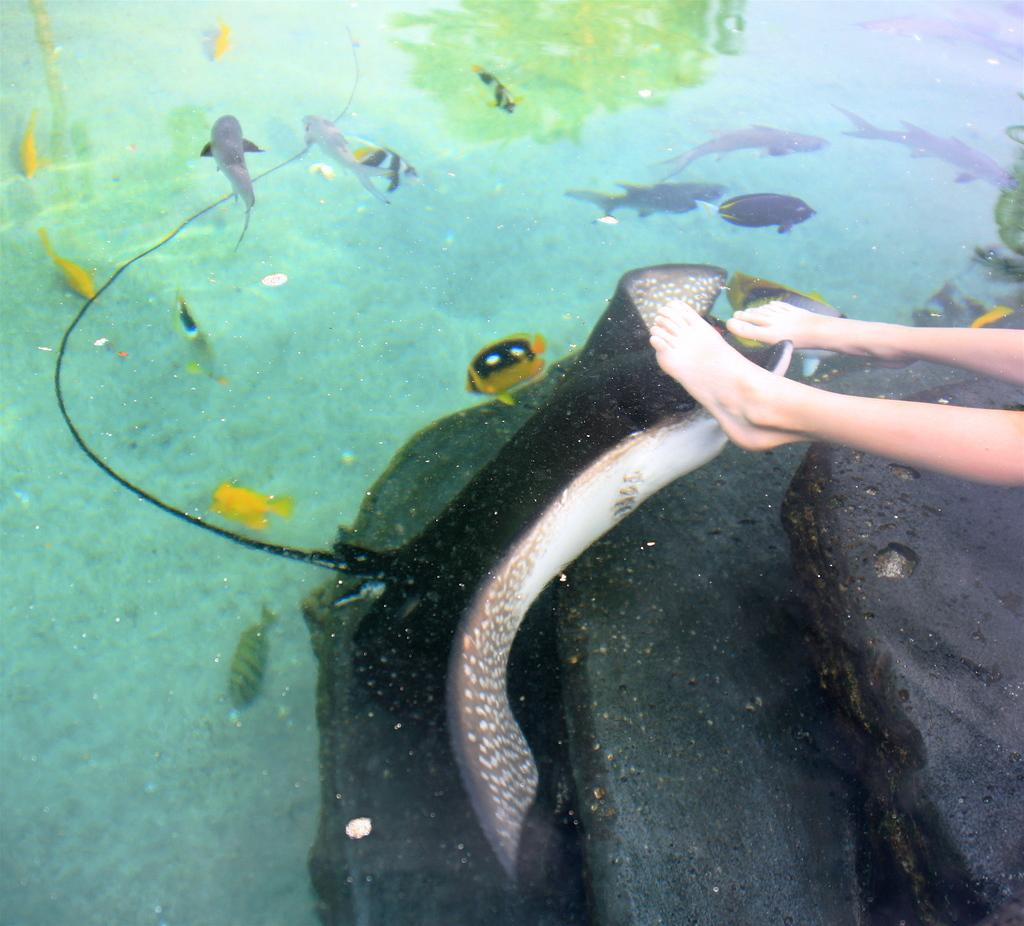What is in the foreground of the picture? There is water in the foreground of the picture. What is the main subject in the center of the image? There is a fish in the center of the image. Can you identify any human presence in the image? Yes, there are legs of a person visible in the image. What else can be seen in the water at the top of the image? There are fishes and plants in the water at the top of the image. What type of map is being used by the fish in the image? There is no map present in the image, and the fish is not using any object. How does the person use the hot water in the image? There is no mention of hot water in the image; it only features water, fish, and plants. 